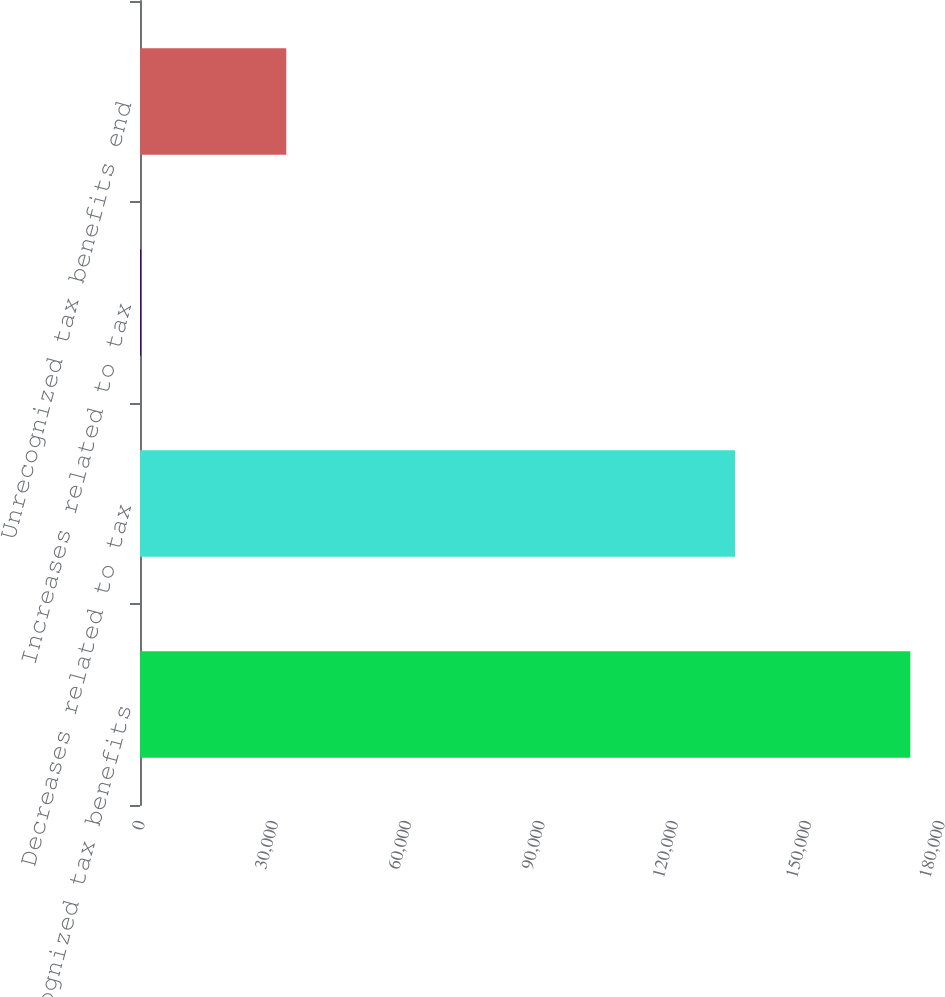Convert chart. <chart><loc_0><loc_0><loc_500><loc_500><bar_chart><fcel>Unrecognized tax benefits<fcel>Decreases related to tax<fcel>Increases related to tax<fcel>Unrecognized tax benefits end<nl><fcel>173310<fcel>133883<fcel>237<fcel>32911<nl></chart> 